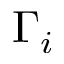Convert formula to latex. <formula><loc_0><loc_0><loc_500><loc_500>\Gamma _ { i }</formula> 